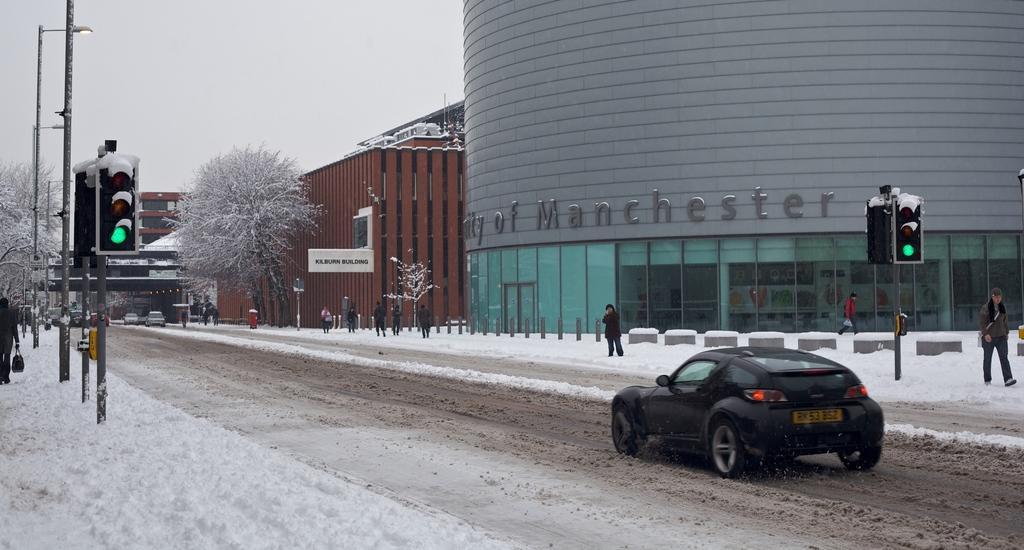Could you give a brief overview of what you see in this image? In the picture I can see car which is black in color is moving on road, there are some persons walking through the walkway, there is snow, there are some poles, traffic signals and in the background of the picture there are some trees, buildings and top of the picture there is clear sky. 